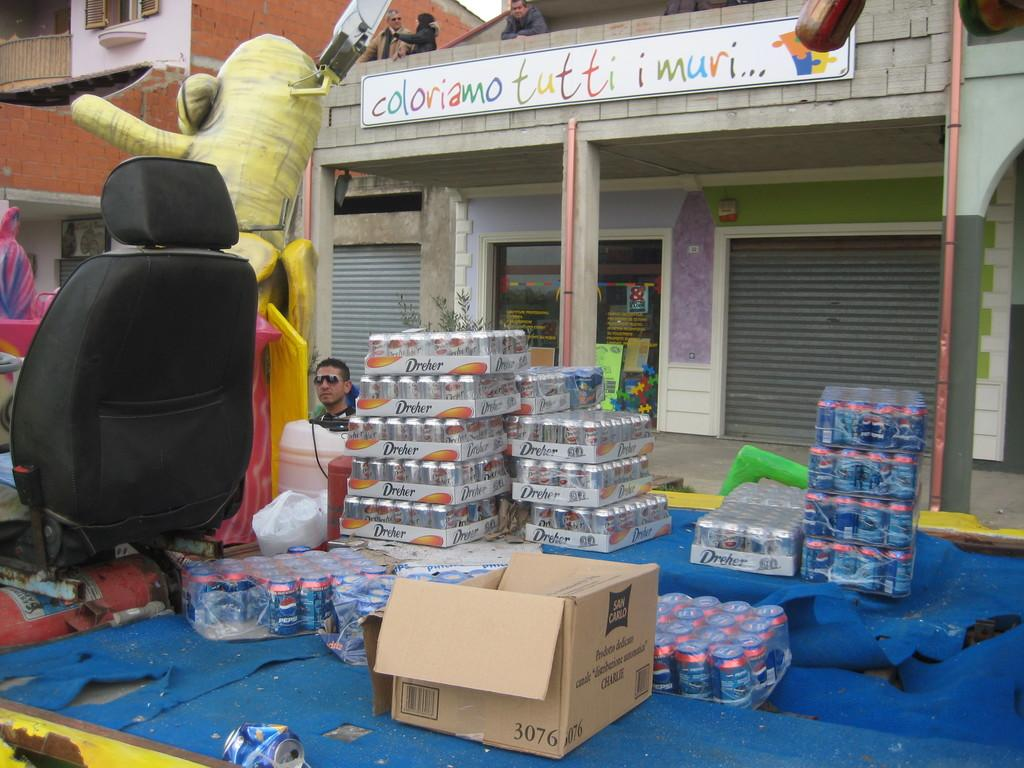<image>
Offer a succinct explanation of the picture presented. a blue tarp with cases of drinks outside a store front reading Coloriano Tutti Imuri 